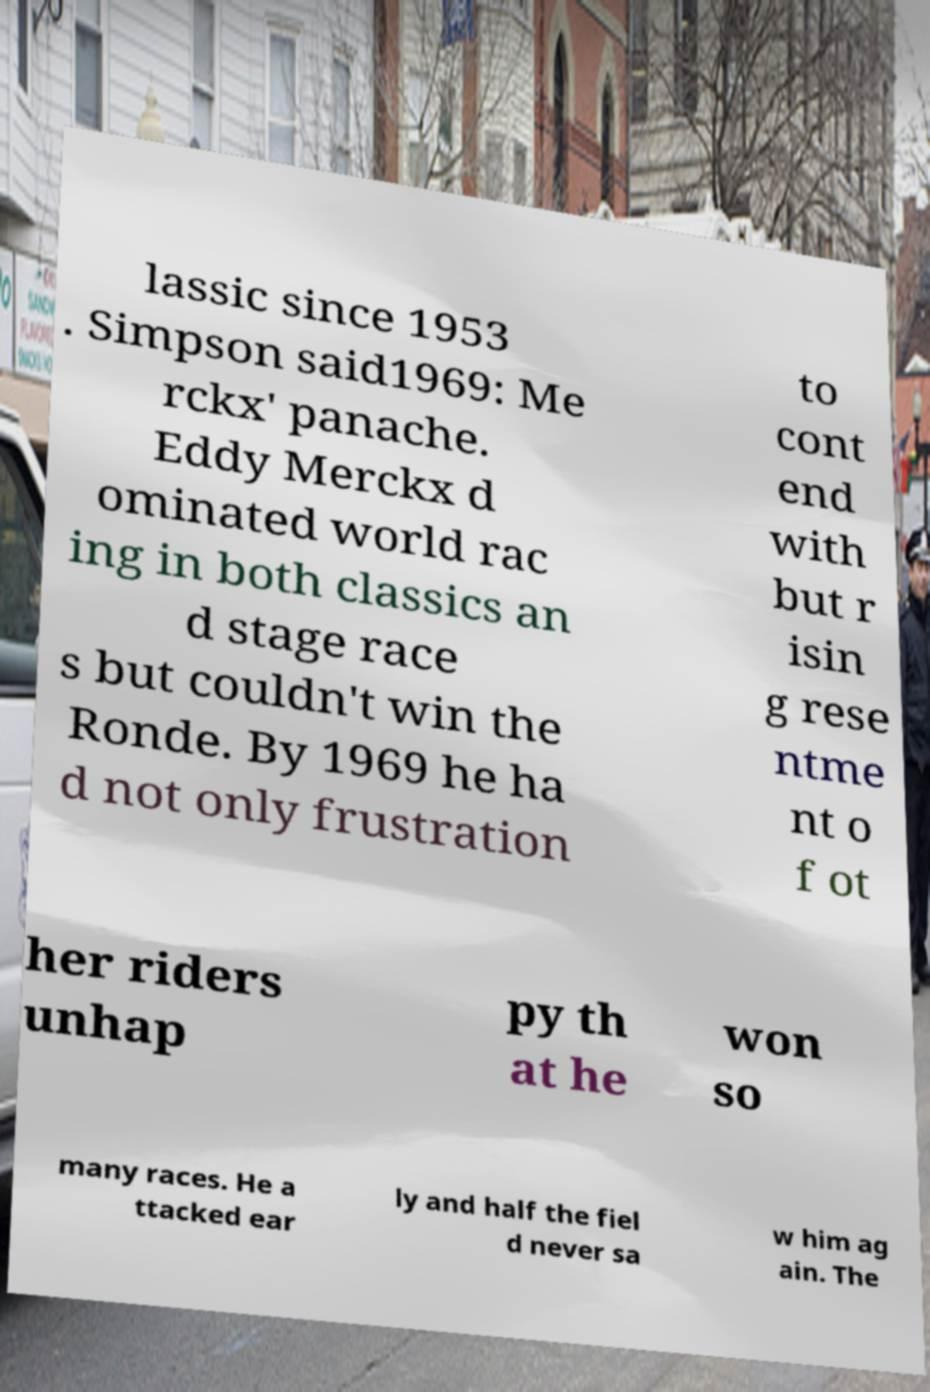Please read and relay the text visible in this image. What does it say? lassic since 1953 . Simpson said1969: Me rckx' panache. Eddy Merckx d ominated world rac ing in both classics an d stage race s but couldn't win the Ronde. By 1969 he ha d not only frustration to cont end with but r isin g rese ntme nt o f ot her riders unhap py th at he won so many races. He a ttacked ear ly and half the fiel d never sa w him ag ain. The 